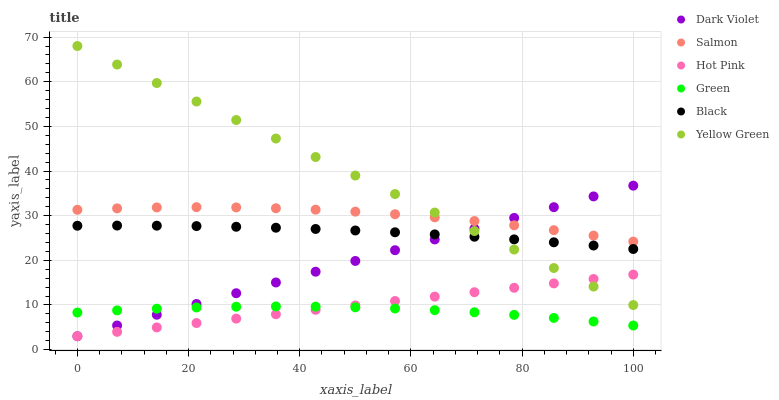Does Green have the minimum area under the curve?
Answer yes or no. Yes. Does Yellow Green have the maximum area under the curve?
Answer yes or no. Yes. Does Hot Pink have the minimum area under the curve?
Answer yes or no. No. Does Hot Pink have the maximum area under the curve?
Answer yes or no. No. Is Hot Pink the smoothest?
Answer yes or no. Yes. Is Salmon the roughest?
Answer yes or no. Yes. Is Salmon the smoothest?
Answer yes or no. No. Is Hot Pink the roughest?
Answer yes or no. No. Does Hot Pink have the lowest value?
Answer yes or no. Yes. Does Salmon have the lowest value?
Answer yes or no. No. Does Yellow Green have the highest value?
Answer yes or no. Yes. Does Hot Pink have the highest value?
Answer yes or no. No. Is Green less than Yellow Green?
Answer yes or no. Yes. Is Black greater than Green?
Answer yes or no. Yes. Does Salmon intersect Dark Violet?
Answer yes or no. Yes. Is Salmon less than Dark Violet?
Answer yes or no. No. Is Salmon greater than Dark Violet?
Answer yes or no. No. Does Green intersect Yellow Green?
Answer yes or no. No. 